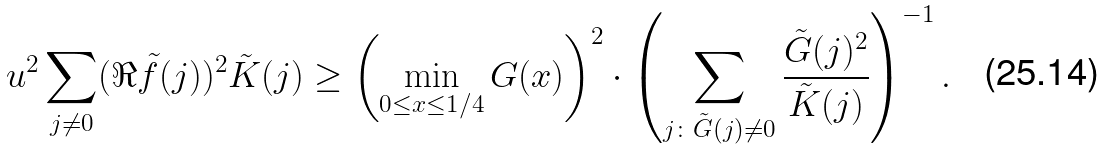<formula> <loc_0><loc_0><loc_500><loc_500>u ^ { 2 } \sum _ { j \ne 0 } ( \Re \tilde { f } ( j ) ) ^ { 2 } \tilde { K } ( j ) \geq \left ( \min _ { 0 \leq x \leq 1 / 4 } G ( x ) \right ) ^ { 2 } \cdot \left ( \sum _ { j \colon \tilde { G } ( j ) \ne 0 } \frac { \tilde { G } ( j ) ^ { 2 } } { \tilde { K } ( j ) } \right ) ^ { - 1 } .</formula> 